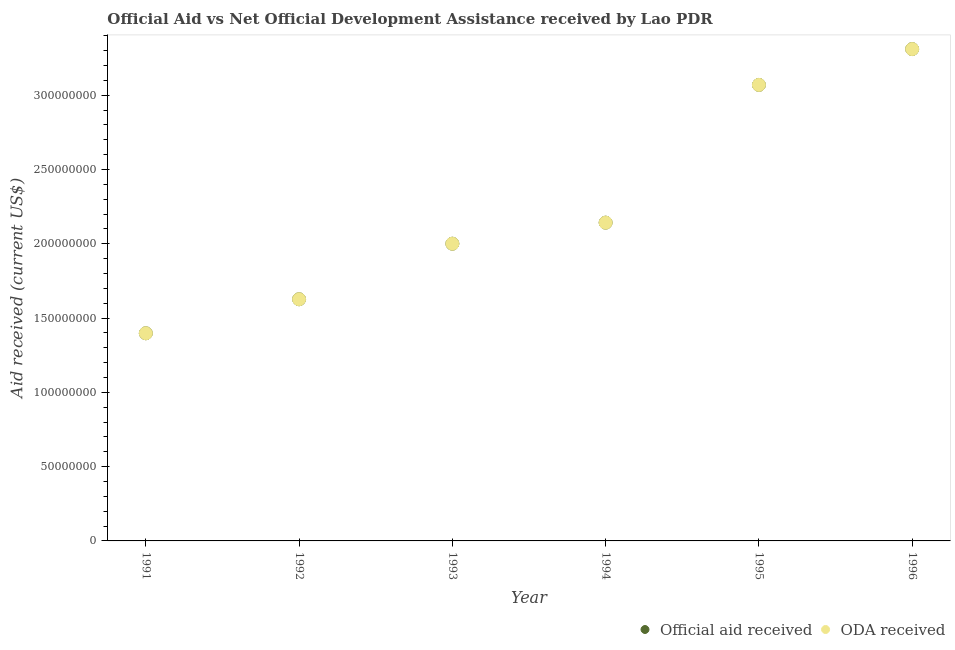Is the number of dotlines equal to the number of legend labels?
Keep it short and to the point. Yes. What is the official aid received in 1996?
Keep it short and to the point. 3.31e+08. Across all years, what is the maximum oda received?
Offer a terse response. 3.31e+08. Across all years, what is the minimum oda received?
Offer a very short reply. 1.40e+08. What is the total official aid received in the graph?
Make the answer very short. 1.35e+09. What is the difference between the oda received in 1992 and that in 1996?
Your response must be concise. -1.68e+08. What is the difference between the oda received in 1994 and the official aid received in 1991?
Give a very brief answer. 7.44e+07. What is the average oda received per year?
Your answer should be compact. 2.26e+08. What is the ratio of the official aid received in 1995 to that in 1996?
Make the answer very short. 0.93. Is the official aid received in 1994 less than that in 1995?
Your answer should be very brief. Yes. What is the difference between the highest and the second highest official aid received?
Your answer should be very brief. 2.41e+07. What is the difference between the highest and the lowest oda received?
Offer a terse response. 1.91e+08. In how many years, is the official aid received greater than the average official aid received taken over all years?
Ensure brevity in your answer.  2. Is the official aid received strictly less than the oda received over the years?
Ensure brevity in your answer.  No. How many years are there in the graph?
Provide a short and direct response. 6. Does the graph contain any zero values?
Your answer should be compact. No. Does the graph contain grids?
Ensure brevity in your answer.  No. How are the legend labels stacked?
Ensure brevity in your answer.  Horizontal. What is the title of the graph?
Offer a terse response. Official Aid vs Net Official Development Assistance received by Lao PDR . What is the label or title of the Y-axis?
Give a very brief answer. Aid received (current US$). What is the Aid received (current US$) in Official aid received in 1991?
Provide a short and direct response. 1.40e+08. What is the Aid received (current US$) in ODA received in 1991?
Provide a succinct answer. 1.40e+08. What is the Aid received (current US$) of Official aid received in 1992?
Ensure brevity in your answer.  1.63e+08. What is the Aid received (current US$) in ODA received in 1992?
Ensure brevity in your answer.  1.63e+08. What is the Aid received (current US$) of Official aid received in 1993?
Provide a succinct answer. 2.00e+08. What is the Aid received (current US$) of ODA received in 1993?
Keep it short and to the point. 2.00e+08. What is the Aid received (current US$) in Official aid received in 1994?
Provide a succinct answer. 2.14e+08. What is the Aid received (current US$) of ODA received in 1994?
Offer a terse response. 2.14e+08. What is the Aid received (current US$) in Official aid received in 1995?
Ensure brevity in your answer.  3.07e+08. What is the Aid received (current US$) of ODA received in 1995?
Your answer should be compact. 3.07e+08. What is the Aid received (current US$) in Official aid received in 1996?
Your response must be concise. 3.31e+08. What is the Aid received (current US$) in ODA received in 1996?
Offer a terse response. 3.31e+08. Across all years, what is the maximum Aid received (current US$) in Official aid received?
Make the answer very short. 3.31e+08. Across all years, what is the maximum Aid received (current US$) in ODA received?
Your answer should be compact. 3.31e+08. Across all years, what is the minimum Aid received (current US$) in Official aid received?
Your answer should be very brief. 1.40e+08. Across all years, what is the minimum Aid received (current US$) of ODA received?
Your answer should be compact. 1.40e+08. What is the total Aid received (current US$) in Official aid received in the graph?
Make the answer very short. 1.35e+09. What is the total Aid received (current US$) of ODA received in the graph?
Your answer should be very brief. 1.35e+09. What is the difference between the Aid received (current US$) of Official aid received in 1991 and that in 1992?
Your answer should be very brief. -2.29e+07. What is the difference between the Aid received (current US$) of ODA received in 1991 and that in 1992?
Offer a terse response. -2.29e+07. What is the difference between the Aid received (current US$) in Official aid received in 1991 and that in 1993?
Make the answer very short. -6.03e+07. What is the difference between the Aid received (current US$) in ODA received in 1991 and that in 1993?
Ensure brevity in your answer.  -6.03e+07. What is the difference between the Aid received (current US$) of Official aid received in 1991 and that in 1994?
Ensure brevity in your answer.  -7.44e+07. What is the difference between the Aid received (current US$) in ODA received in 1991 and that in 1994?
Provide a short and direct response. -7.44e+07. What is the difference between the Aid received (current US$) in Official aid received in 1991 and that in 1995?
Make the answer very short. -1.67e+08. What is the difference between the Aid received (current US$) of ODA received in 1991 and that in 1995?
Make the answer very short. -1.67e+08. What is the difference between the Aid received (current US$) in Official aid received in 1991 and that in 1996?
Provide a succinct answer. -1.91e+08. What is the difference between the Aid received (current US$) in ODA received in 1991 and that in 1996?
Give a very brief answer. -1.91e+08. What is the difference between the Aid received (current US$) of Official aid received in 1992 and that in 1993?
Your response must be concise. -3.74e+07. What is the difference between the Aid received (current US$) in ODA received in 1992 and that in 1993?
Your answer should be very brief. -3.74e+07. What is the difference between the Aid received (current US$) of Official aid received in 1992 and that in 1994?
Ensure brevity in your answer.  -5.16e+07. What is the difference between the Aid received (current US$) in ODA received in 1992 and that in 1994?
Your answer should be very brief. -5.16e+07. What is the difference between the Aid received (current US$) in Official aid received in 1992 and that in 1995?
Make the answer very short. -1.44e+08. What is the difference between the Aid received (current US$) in ODA received in 1992 and that in 1995?
Offer a terse response. -1.44e+08. What is the difference between the Aid received (current US$) of Official aid received in 1992 and that in 1996?
Your response must be concise. -1.68e+08. What is the difference between the Aid received (current US$) of ODA received in 1992 and that in 1996?
Provide a succinct answer. -1.68e+08. What is the difference between the Aid received (current US$) of Official aid received in 1993 and that in 1994?
Offer a very short reply. -1.42e+07. What is the difference between the Aid received (current US$) of ODA received in 1993 and that in 1994?
Offer a very short reply. -1.42e+07. What is the difference between the Aid received (current US$) of Official aid received in 1993 and that in 1995?
Offer a terse response. -1.07e+08. What is the difference between the Aid received (current US$) in ODA received in 1993 and that in 1995?
Your response must be concise. -1.07e+08. What is the difference between the Aid received (current US$) in Official aid received in 1993 and that in 1996?
Offer a very short reply. -1.31e+08. What is the difference between the Aid received (current US$) of ODA received in 1993 and that in 1996?
Keep it short and to the point. -1.31e+08. What is the difference between the Aid received (current US$) in Official aid received in 1994 and that in 1995?
Your answer should be compact. -9.27e+07. What is the difference between the Aid received (current US$) in ODA received in 1994 and that in 1995?
Provide a short and direct response. -9.27e+07. What is the difference between the Aid received (current US$) in Official aid received in 1994 and that in 1996?
Give a very brief answer. -1.17e+08. What is the difference between the Aid received (current US$) of ODA received in 1994 and that in 1996?
Your response must be concise. -1.17e+08. What is the difference between the Aid received (current US$) of Official aid received in 1995 and that in 1996?
Make the answer very short. -2.41e+07. What is the difference between the Aid received (current US$) in ODA received in 1995 and that in 1996?
Make the answer very short. -2.41e+07. What is the difference between the Aid received (current US$) of Official aid received in 1991 and the Aid received (current US$) of ODA received in 1992?
Your answer should be very brief. -2.29e+07. What is the difference between the Aid received (current US$) of Official aid received in 1991 and the Aid received (current US$) of ODA received in 1993?
Make the answer very short. -6.03e+07. What is the difference between the Aid received (current US$) of Official aid received in 1991 and the Aid received (current US$) of ODA received in 1994?
Your response must be concise. -7.44e+07. What is the difference between the Aid received (current US$) of Official aid received in 1991 and the Aid received (current US$) of ODA received in 1995?
Ensure brevity in your answer.  -1.67e+08. What is the difference between the Aid received (current US$) in Official aid received in 1991 and the Aid received (current US$) in ODA received in 1996?
Provide a short and direct response. -1.91e+08. What is the difference between the Aid received (current US$) of Official aid received in 1992 and the Aid received (current US$) of ODA received in 1993?
Your answer should be compact. -3.74e+07. What is the difference between the Aid received (current US$) of Official aid received in 1992 and the Aid received (current US$) of ODA received in 1994?
Make the answer very short. -5.16e+07. What is the difference between the Aid received (current US$) in Official aid received in 1992 and the Aid received (current US$) in ODA received in 1995?
Your response must be concise. -1.44e+08. What is the difference between the Aid received (current US$) in Official aid received in 1992 and the Aid received (current US$) in ODA received in 1996?
Provide a succinct answer. -1.68e+08. What is the difference between the Aid received (current US$) of Official aid received in 1993 and the Aid received (current US$) of ODA received in 1994?
Keep it short and to the point. -1.42e+07. What is the difference between the Aid received (current US$) in Official aid received in 1993 and the Aid received (current US$) in ODA received in 1995?
Make the answer very short. -1.07e+08. What is the difference between the Aid received (current US$) in Official aid received in 1993 and the Aid received (current US$) in ODA received in 1996?
Your answer should be compact. -1.31e+08. What is the difference between the Aid received (current US$) of Official aid received in 1994 and the Aid received (current US$) of ODA received in 1995?
Your response must be concise. -9.27e+07. What is the difference between the Aid received (current US$) of Official aid received in 1994 and the Aid received (current US$) of ODA received in 1996?
Ensure brevity in your answer.  -1.17e+08. What is the difference between the Aid received (current US$) of Official aid received in 1995 and the Aid received (current US$) of ODA received in 1996?
Ensure brevity in your answer.  -2.41e+07. What is the average Aid received (current US$) of Official aid received per year?
Offer a terse response. 2.26e+08. What is the average Aid received (current US$) in ODA received per year?
Offer a terse response. 2.26e+08. In the year 1992, what is the difference between the Aid received (current US$) in Official aid received and Aid received (current US$) in ODA received?
Offer a terse response. 0. In the year 1993, what is the difference between the Aid received (current US$) in Official aid received and Aid received (current US$) in ODA received?
Your response must be concise. 0. In the year 1994, what is the difference between the Aid received (current US$) of Official aid received and Aid received (current US$) of ODA received?
Provide a short and direct response. 0. In the year 1995, what is the difference between the Aid received (current US$) of Official aid received and Aid received (current US$) of ODA received?
Your answer should be very brief. 0. What is the ratio of the Aid received (current US$) of Official aid received in 1991 to that in 1992?
Make the answer very short. 0.86. What is the ratio of the Aid received (current US$) in ODA received in 1991 to that in 1992?
Keep it short and to the point. 0.86. What is the ratio of the Aid received (current US$) of Official aid received in 1991 to that in 1993?
Keep it short and to the point. 0.7. What is the ratio of the Aid received (current US$) in ODA received in 1991 to that in 1993?
Provide a succinct answer. 0.7. What is the ratio of the Aid received (current US$) of Official aid received in 1991 to that in 1994?
Make the answer very short. 0.65. What is the ratio of the Aid received (current US$) of ODA received in 1991 to that in 1994?
Give a very brief answer. 0.65. What is the ratio of the Aid received (current US$) of Official aid received in 1991 to that in 1995?
Keep it short and to the point. 0.46. What is the ratio of the Aid received (current US$) of ODA received in 1991 to that in 1995?
Ensure brevity in your answer.  0.46. What is the ratio of the Aid received (current US$) in Official aid received in 1991 to that in 1996?
Provide a succinct answer. 0.42. What is the ratio of the Aid received (current US$) of ODA received in 1991 to that in 1996?
Provide a succinct answer. 0.42. What is the ratio of the Aid received (current US$) of Official aid received in 1992 to that in 1993?
Provide a succinct answer. 0.81. What is the ratio of the Aid received (current US$) in ODA received in 1992 to that in 1993?
Give a very brief answer. 0.81. What is the ratio of the Aid received (current US$) of Official aid received in 1992 to that in 1994?
Provide a succinct answer. 0.76. What is the ratio of the Aid received (current US$) of ODA received in 1992 to that in 1994?
Your answer should be very brief. 0.76. What is the ratio of the Aid received (current US$) in Official aid received in 1992 to that in 1995?
Your answer should be very brief. 0.53. What is the ratio of the Aid received (current US$) in ODA received in 1992 to that in 1995?
Keep it short and to the point. 0.53. What is the ratio of the Aid received (current US$) in Official aid received in 1992 to that in 1996?
Keep it short and to the point. 0.49. What is the ratio of the Aid received (current US$) in ODA received in 1992 to that in 1996?
Provide a succinct answer. 0.49. What is the ratio of the Aid received (current US$) of Official aid received in 1993 to that in 1994?
Keep it short and to the point. 0.93. What is the ratio of the Aid received (current US$) of ODA received in 1993 to that in 1994?
Offer a terse response. 0.93. What is the ratio of the Aid received (current US$) in Official aid received in 1993 to that in 1995?
Ensure brevity in your answer.  0.65. What is the ratio of the Aid received (current US$) of ODA received in 1993 to that in 1995?
Provide a short and direct response. 0.65. What is the ratio of the Aid received (current US$) in Official aid received in 1993 to that in 1996?
Your answer should be compact. 0.6. What is the ratio of the Aid received (current US$) in ODA received in 1993 to that in 1996?
Offer a very short reply. 0.6. What is the ratio of the Aid received (current US$) in Official aid received in 1994 to that in 1995?
Your answer should be very brief. 0.7. What is the ratio of the Aid received (current US$) of ODA received in 1994 to that in 1995?
Provide a succinct answer. 0.7. What is the ratio of the Aid received (current US$) in Official aid received in 1994 to that in 1996?
Keep it short and to the point. 0.65. What is the ratio of the Aid received (current US$) in ODA received in 1994 to that in 1996?
Provide a short and direct response. 0.65. What is the ratio of the Aid received (current US$) of Official aid received in 1995 to that in 1996?
Offer a very short reply. 0.93. What is the ratio of the Aid received (current US$) in ODA received in 1995 to that in 1996?
Offer a very short reply. 0.93. What is the difference between the highest and the second highest Aid received (current US$) in Official aid received?
Your answer should be compact. 2.41e+07. What is the difference between the highest and the second highest Aid received (current US$) of ODA received?
Provide a short and direct response. 2.41e+07. What is the difference between the highest and the lowest Aid received (current US$) in Official aid received?
Offer a terse response. 1.91e+08. What is the difference between the highest and the lowest Aid received (current US$) of ODA received?
Provide a short and direct response. 1.91e+08. 